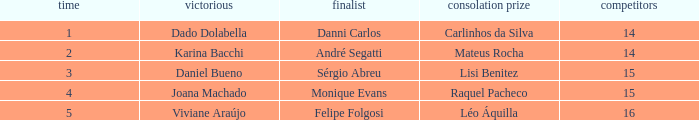Who finished in third place when the winner was Karina Bacchi?  Mateus Rocha. 